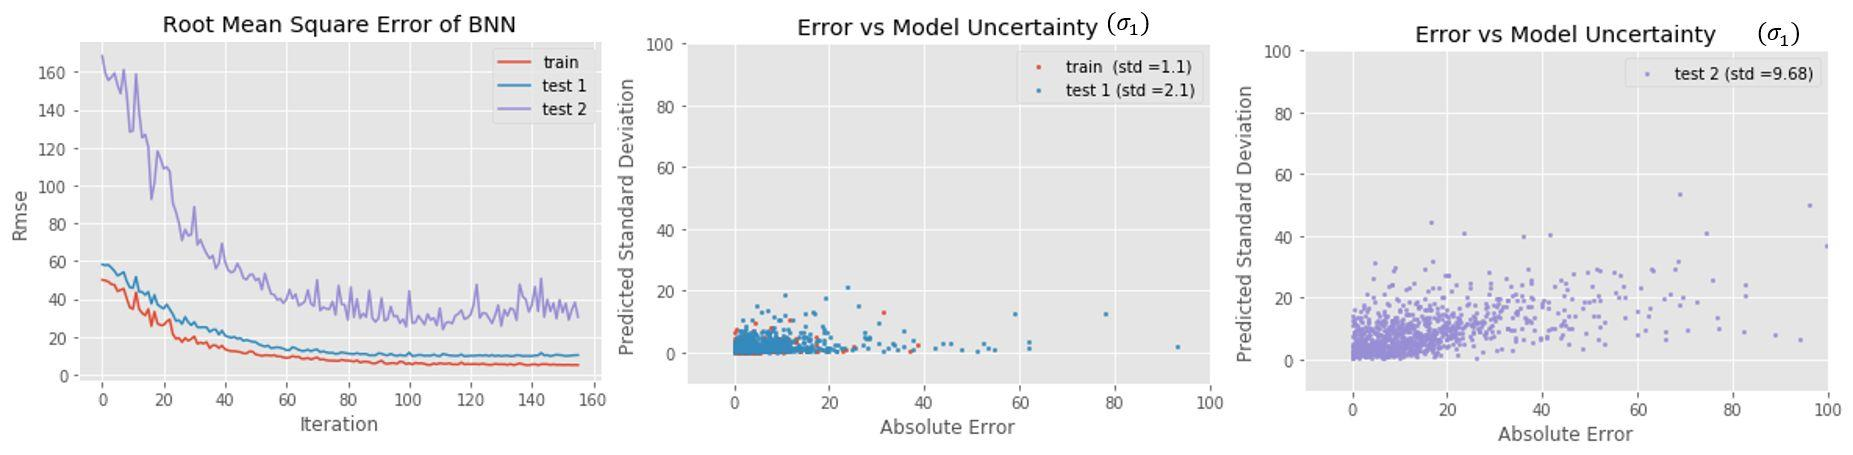How could we reduce model uncertainty in future tests? Reducing model uncertainty can be approached in several ways. One could improve the quality and quantity of the training data used to build the model, perhaps by including more representative samples or by cleaning the data to remove noise and outliers. Refining the model itself by selecting a more appropriate algorithm or fine-tuning hyperparameters may also help. Additionally, incorporating ensemble methods that aggregate predictions from multiple models can often lead to more robust, less uncertain predictions. 